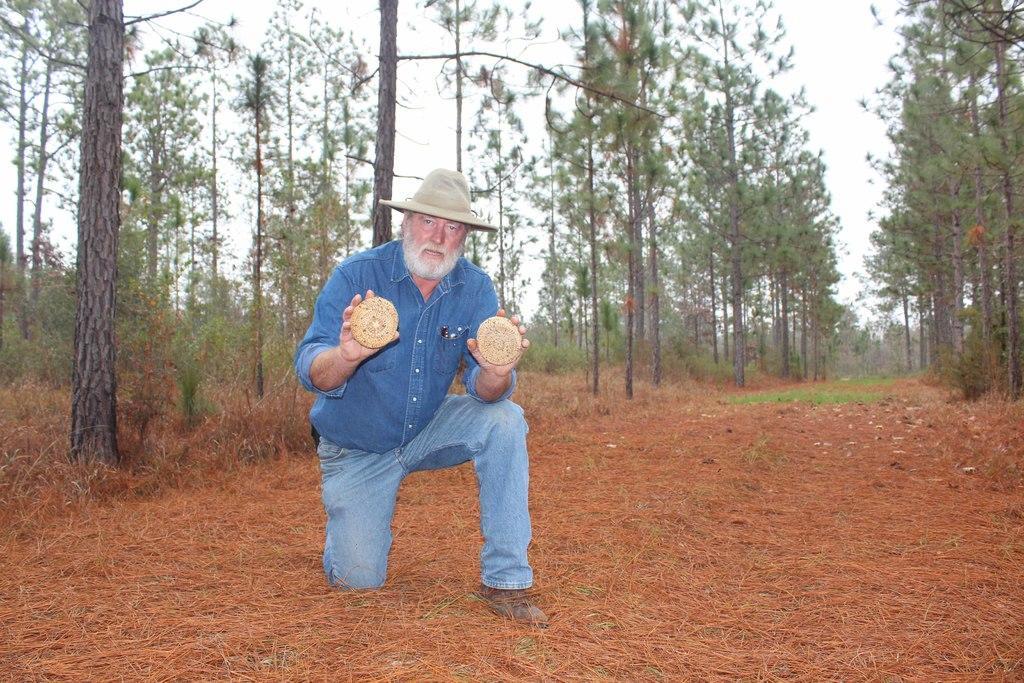Describe this image in one or two sentences. In this picture we can see a person on the ground, he is wearing a hat and holding some objects and in the background we can see dried grass, trees, sky. 